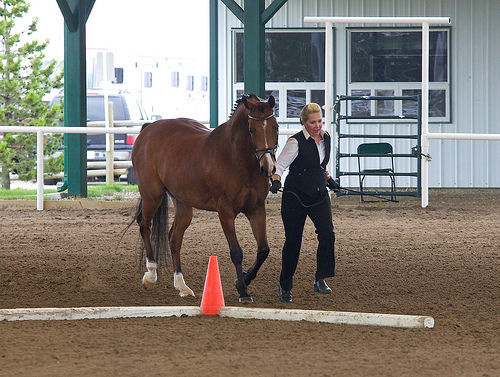<image>
Is there a woman on the horse? No. The woman is not positioned on the horse. They may be near each other, but the woman is not supported by or resting on top of the horse. Is there a horse behind the cone? Yes. From this viewpoint, the horse is positioned behind the cone, with the cone partially or fully occluding the horse. 